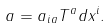Convert formula to latex. <formula><loc_0><loc_0><loc_500><loc_500>a = a _ { i a } T ^ { a } d x ^ { i } .</formula> 